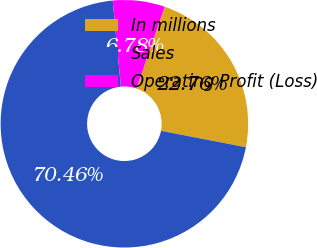Convert chart to OTSL. <chart><loc_0><loc_0><loc_500><loc_500><pie_chart><fcel>In millions<fcel>Sales<fcel>Operating Profit (Loss)<nl><fcel>22.76%<fcel>70.47%<fcel>6.78%<nl></chart> 